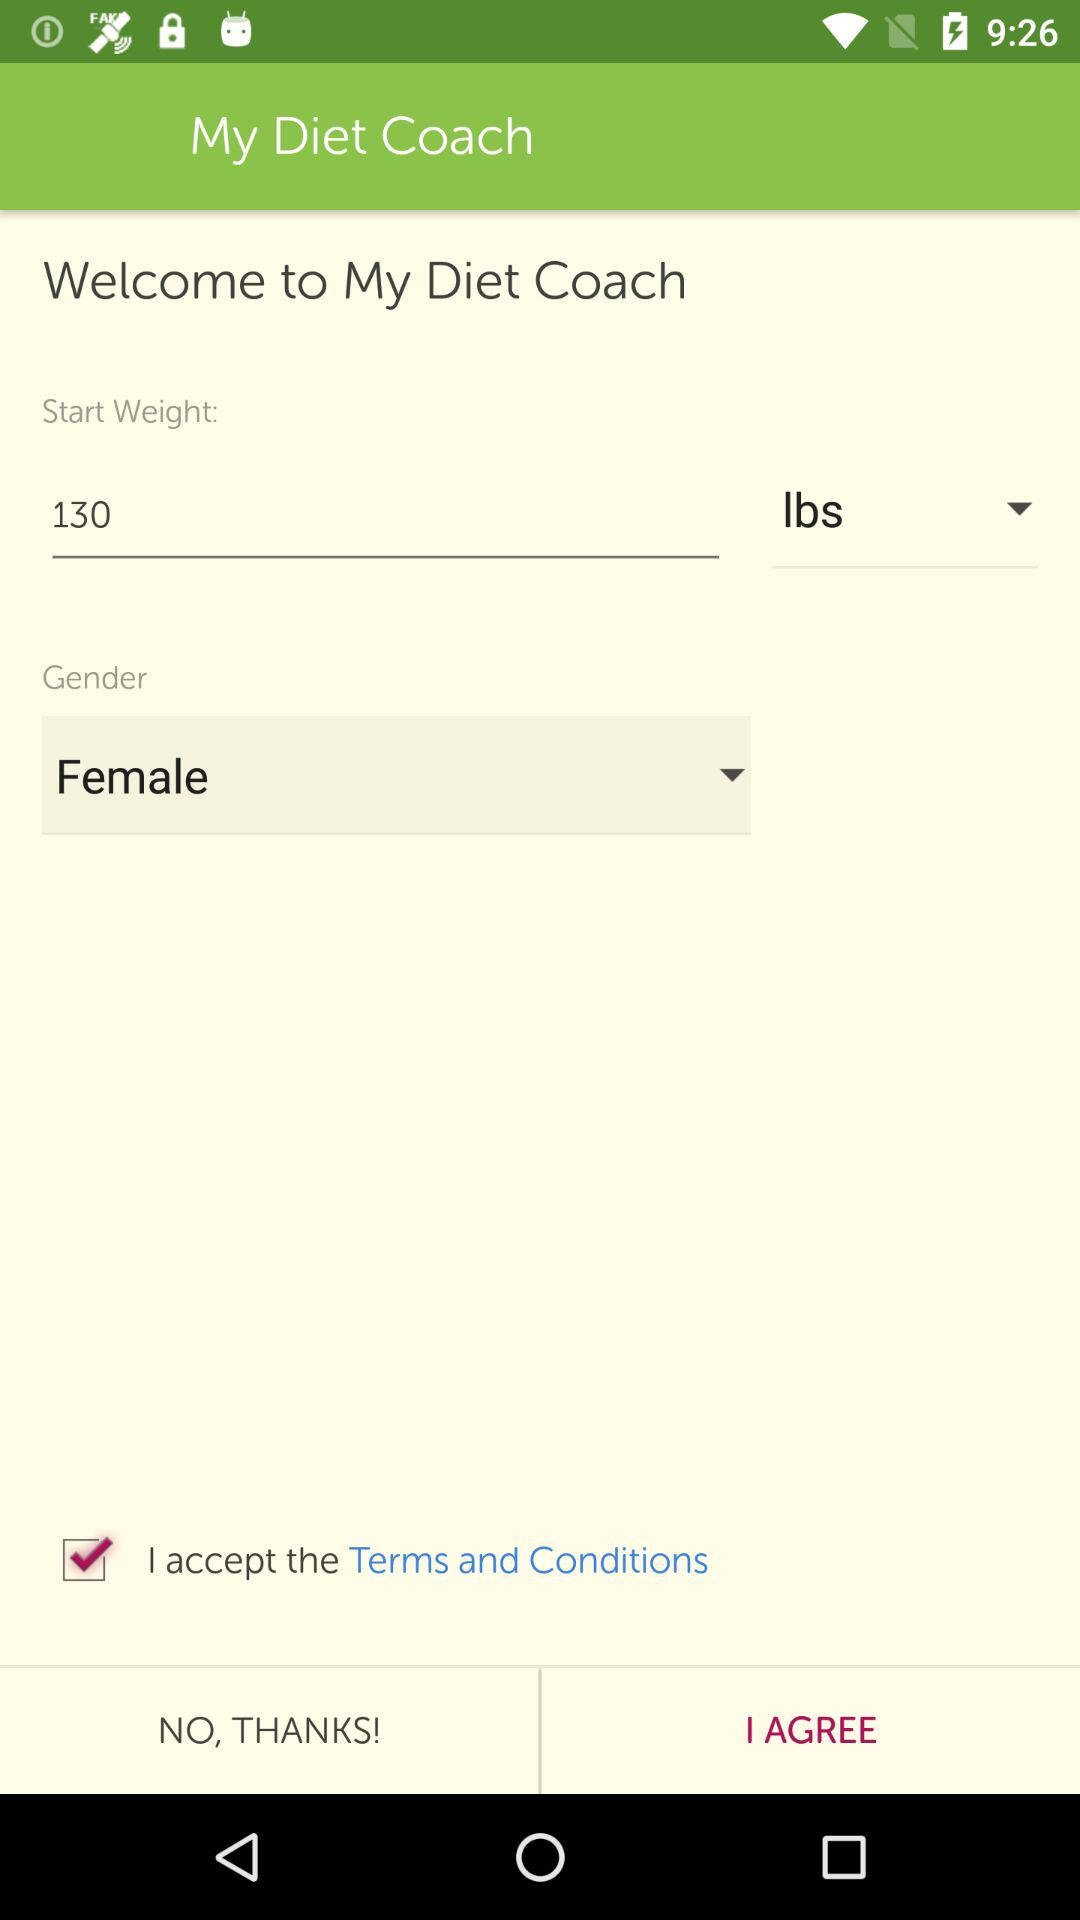What is the end weight?
When the provided information is insufficient, respond with <no answer>. <no answer> 